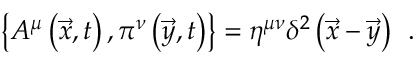Convert formula to latex. <formula><loc_0><loc_0><loc_500><loc_500>\left \{ A ^ { \mu } \left ( \vec { x } , t \right ) , \pi ^ { \nu } \left ( \vec { y } , t \right ) \right \} = \eta ^ { \mu \nu } \delta ^ { 2 } \left ( \vec { x } - \vec { y } \right ) \, .</formula> 